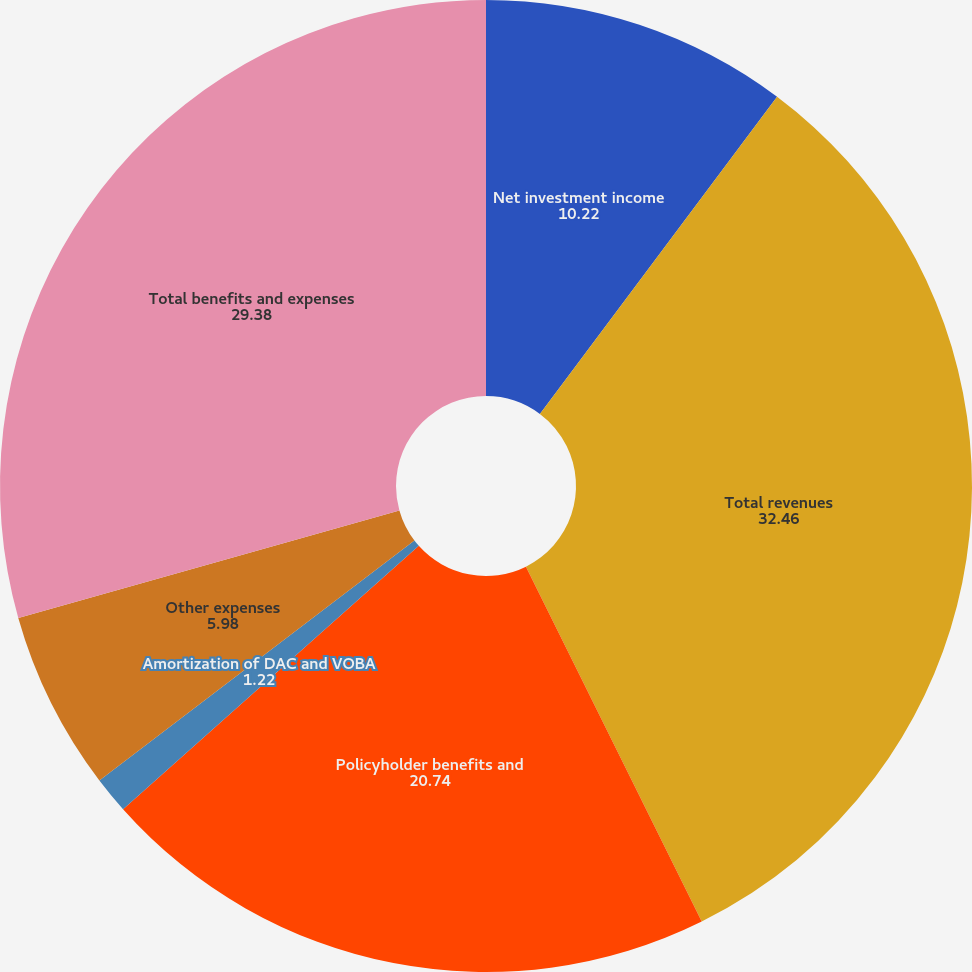<chart> <loc_0><loc_0><loc_500><loc_500><pie_chart><fcel>Net investment income<fcel>Total revenues<fcel>Policyholder benefits and<fcel>Amortization of DAC and VOBA<fcel>Other expenses<fcel>Total benefits and expenses<nl><fcel>10.22%<fcel>32.46%<fcel>20.74%<fcel>1.22%<fcel>5.98%<fcel>29.38%<nl></chart> 